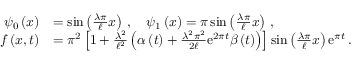Convert formula to latex. <formula><loc_0><loc_0><loc_500><loc_500>\begin{array} { r l } { { \psi } _ { 0 } \left ( x \right ) } & { = \sin \left ( \frac { \lambda \pi } { \ell } x \right ) \, , \quad \psi _ { 1 } \left ( x \right ) = { \pi } \sin \left ( \frac { \lambda \pi } { \ell } x \right ) \, , } \\ { f \left ( x , t \right ) } & { = { \pi } ^ { 2 } \left [ 1 + \frac { { \lambda } ^ { 2 } } { { \ell } ^ { 2 } } \left ( \alpha \left ( t \right ) + \frac { { \lambda } ^ { 2 } { \pi } ^ { 2 } } { 2 \ell } { e } ^ { 2 \pi t } \beta \left ( t \right ) \right ) \right ] \sin \left ( \frac { \lambda \pi } { \ell } x \right ) { e } ^ { \pi t } \, . } \end{array}</formula> 